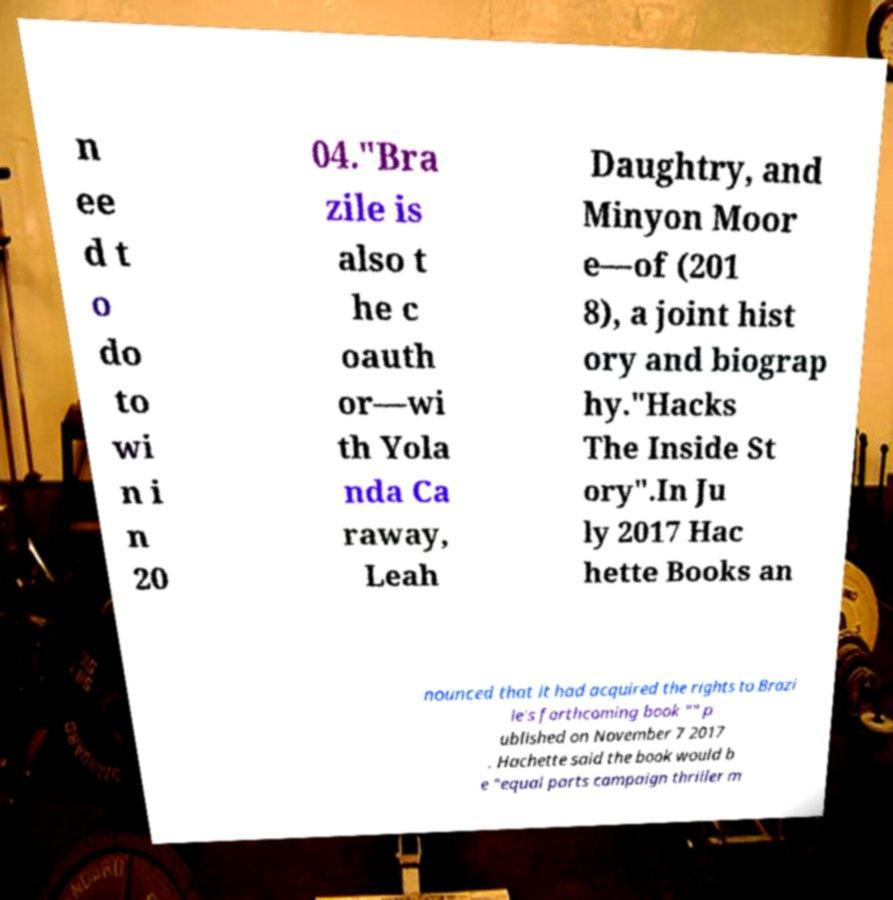Please identify and transcribe the text found in this image. n ee d t o do to wi n i n 20 04."Bra zile is also t he c oauth or—wi th Yola nda Ca raway, Leah Daughtry, and Minyon Moor e—of (201 8), a joint hist ory and biograp hy."Hacks The Inside St ory".In Ju ly 2017 Hac hette Books an nounced that it had acquired the rights to Brazi le's forthcoming book "" p ublished on November 7 2017 . Hachette said the book would b e "equal parts campaign thriller m 